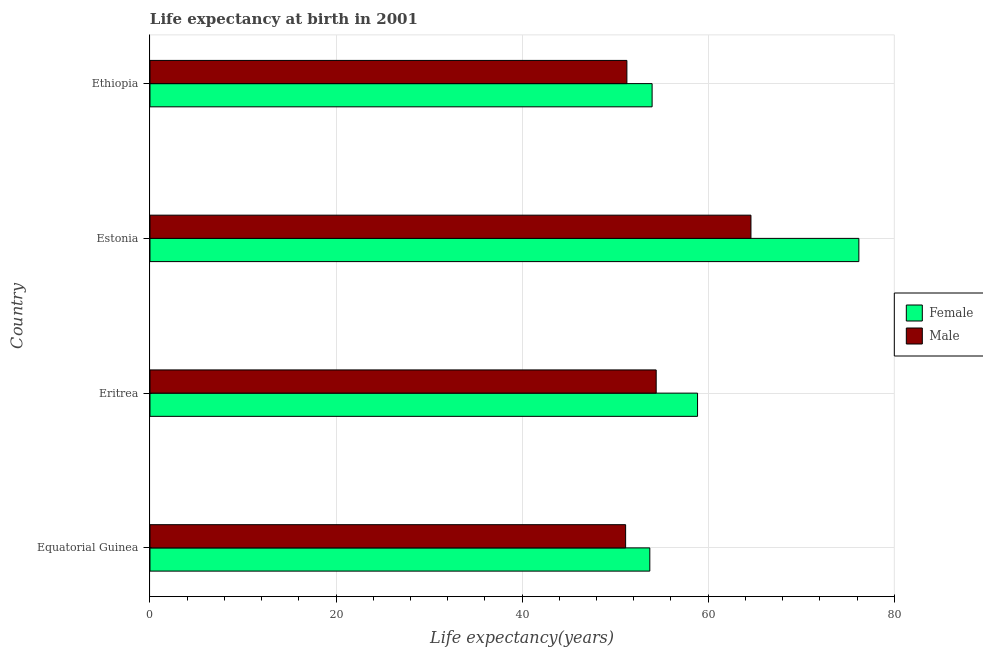How many groups of bars are there?
Ensure brevity in your answer.  4. Are the number of bars per tick equal to the number of legend labels?
Your answer should be very brief. Yes. Are the number of bars on each tick of the Y-axis equal?
Your answer should be very brief. Yes. How many bars are there on the 2nd tick from the bottom?
Offer a very short reply. 2. What is the label of the 4th group of bars from the top?
Your response must be concise. Equatorial Guinea. What is the life expectancy(female) in Equatorial Guinea?
Keep it short and to the point. 53.73. Across all countries, what is the maximum life expectancy(female)?
Your answer should be compact. 76.2. Across all countries, what is the minimum life expectancy(female)?
Your response must be concise. 53.73. In which country was the life expectancy(male) maximum?
Ensure brevity in your answer.  Estonia. In which country was the life expectancy(male) minimum?
Ensure brevity in your answer.  Equatorial Guinea. What is the total life expectancy(female) in the graph?
Provide a succinct answer. 242.76. What is the difference between the life expectancy(male) in Equatorial Guinea and that in Eritrea?
Offer a very short reply. -3.29. What is the difference between the life expectancy(female) in Estonia and the life expectancy(male) in Equatorial Guinea?
Provide a succinct answer. 25.07. What is the average life expectancy(male) per country?
Provide a short and direct response. 55.35. What is the difference between the life expectancy(male) and life expectancy(female) in Equatorial Guinea?
Give a very brief answer. -2.6. In how many countries, is the life expectancy(female) greater than 44 years?
Offer a very short reply. 4. What is the difference between the highest and the second highest life expectancy(male)?
Offer a very short reply. 10.19. What is the difference between the highest and the lowest life expectancy(male)?
Provide a short and direct response. 13.47. In how many countries, is the life expectancy(female) greater than the average life expectancy(female) taken over all countries?
Make the answer very short. 1. Is the sum of the life expectancy(male) in Equatorial Guinea and Estonia greater than the maximum life expectancy(female) across all countries?
Your answer should be very brief. Yes. What does the 1st bar from the top in Equatorial Guinea represents?
Your response must be concise. Male. How many bars are there?
Ensure brevity in your answer.  8. How many legend labels are there?
Give a very brief answer. 2. What is the title of the graph?
Make the answer very short. Life expectancy at birth in 2001. Does "Measles" appear as one of the legend labels in the graph?
Offer a terse response. No. What is the label or title of the X-axis?
Your response must be concise. Life expectancy(years). What is the Life expectancy(years) in Female in Equatorial Guinea?
Make the answer very short. 53.73. What is the Life expectancy(years) of Male in Equatorial Guinea?
Offer a very short reply. 51.13. What is the Life expectancy(years) of Female in Eritrea?
Your response must be concise. 58.86. What is the Life expectancy(years) in Male in Eritrea?
Ensure brevity in your answer.  54.41. What is the Life expectancy(years) of Female in Estonia?
Provide a succinct answer. 76.2. What is the Life expectancy(years) of Male in Estonia?
Your response must be concise. 64.6. What is the Life expectancy(years) of Female in Ethiopia?
Provide a succinct answer. 53.98. What is the Life expectancy(years) of Male in Ethiopia?
Keep it short and to the point. 51.26. Across all countries, what is the maximum Life expectancy(years) in Female?
Provide a succinct answer. 76.2. Across all countries, what is the maximum Life expectancy(years) of Male?
Offer a terse response. 64.6. Across all countries, what is the minimum Life expectancy(years) of Female?
Your answer should be compact. 53.73. Across all countries, what is the minimum Life expectancy(years) of Male?
Offer a terse response. 51.13. What is the total Life expectancy(years) in Female in the graph?
Ensure brevity in your answer.  242.76. What is the total Life expectancy(years) of Male in the graph?
Offer a terse response. 221.41. What is the difference between the Life expectancy(years) of Female in Equatorial Guinea and that in Eritrea?
Your answer should be very brief. -5.13. What is the difference between the Life expectancy(years) of Male in Equatorial Guinea and that in Eritrea?
Provide a short and direct response. -3.29. What is the difference between the Life expectancy(years) of Female in Equatorial Guinea and that in Estonia?
Keep it short and to the point. -22.47. What is the difference between the Life expectancy(years) of Male in Equatorial Guinea and that in Estonia?
Make the answer very short. -13.47. What is the difference between the Life expectancy(years) in Female in Equatorial Guinea and that in Ethiopia?
Provide a succinct answer. -0.25. What is the difference between the Life expectancy(years) in Male in Equatorial Guinea and that in Ethiopia?
Offer a very short reply. -0.14. What is the difference between the Life expectancy(years) in Female in Eritrea and that in Estonia?
Ensure brevity in your answer.  -17.34. What is the difference between the Life expectancy(years) in Male in Eritrea and that in Estonia?
Provide a succinct answer. -10.19. What is the difference between the Life expectancy(years) of Female in Eritrea and that in Ethiopia?
Your answer should be very brief. 4.88. What is the difference between the Life expectancy(years) of Male in Eritrea and that in Ethiopia?
Offer a very short reply. 3.15. What is the difference between the Life expectancy(years) of Female in Estonia and that in Ethiopia?
Provide a short and direct response. 22.22. What is the difference between the Life expectancy(years) of Male in Estonia and that in Ethiopia?
Provide a succinct answer. 13.34. What is the difference between the Life expectancy(years) in Female in Equatorial Guinea and the Life expectancy(years) in Male in Eritrea?
Keep it short and to the point. -0.69. What is the difference between the Life expectancy(years) of Female in Equatorial Guinea and the Life expectancy(years) of Male in Estonia?
Make the answer very short. -10.87. What is the difference between the Life expectancy(years) of Female in Equatorial Guinea and the Life expectancy(years) of Male in Ethiopia?
Your answer should be compact. 2.46. What is the difference between the Life expectancy(years) of Female in Eritrea and the Life expectancy(years) of Male in Estonia?
Provide a short and direct response. -5.74. What is the difference between the Life expectancy(years) of Female in Eritrea and the Life expectancy(years) of Male in Ethiopia?
Provide a short and direct response. 7.6. What is the difference between the Life expectancy(years) in Female in Estonia and the Life expectancy(years) in Male in Ethiopia?
Ensure brevity in your answer.  24.94. What is the average Life expectancy(years) in Female per country?
Give a very brief answer. 60.69. What is the average Life expectancy(years) of Male per country?
Provide a succinct answer. 55.35. What is the difference between the Life expectancy(years) of Female and Life expectancy(years) of Male in Equatorial Guinea?
Make the answer very short. 2.6. What is the difference between the Life expectancy(years) in Female and Life expectancy(years) in Male in Eritrea?
Your answer should be very brief. 4.45. What is the difference between the Life expectancy(years) in Female and Life expectancy(years) in Male in Ethiopia?
Provide a short and direct response. 2.71. What is the ratio of the Life expectancy(years) in Female in Equatorial Guinea to that in Eritrea?
Your response must be concise. 0.91. What is the ratio of the Life expectancy(years) in Male in Equatorial Guinea to that in Eritrea?
Offer a terse response. 0.94. What is the ratio of the Life expectancy(years) in Female in Equatorial Guinea to that in Estonia?
Offer a terse response. 0.71. What is the ratio of the Life expectancy(years) in Male in Equatorial Guinea to that in Estonia?
Keep it short and to the point. 0.79. What is the ratio of the Life expectancy(years) in Female in Eritrea to that in Estonia?
Your answer should be compact. 0.77. What is the ratio of the Life expectancy(years) in Male in Eritrea to that in Estonia?
Your answer should be very brief. 0.84. What is the ratio of the Life expectancy(years) in Female in Eritrea to that in Ethiopia?
Provide a succinct answer. 1.09. What is the ratio of the Life expectancy(years) of Male in Eritrea to that in Ethiopia?
Offer a very short reply. 1.06. What is the ratio of the Life expectancy(years) in Female in Estonia to that in Ethiopia?
Your answer should be very brief. 1.41. What is the ratio of the Life expectancy(years) of Male in Estonia to that in Ethiopia?
Your answer should be compact. 1.26. What is the difference between the highest and the second highest Life expectancy(years) in Female?
Make the answer very short. 17.34. What is the difference between the highest and the second highest Life expectancy(years) in Male?
Make the answer very short. 10.19. What is the difference between the highest and the lowest Life expectancy(years) of Female?
Your answer should be compact. 22.47. What is the difference between the highest and the lowest Life expectancy(years) of Male?
Your response must be concise. 13.47. 